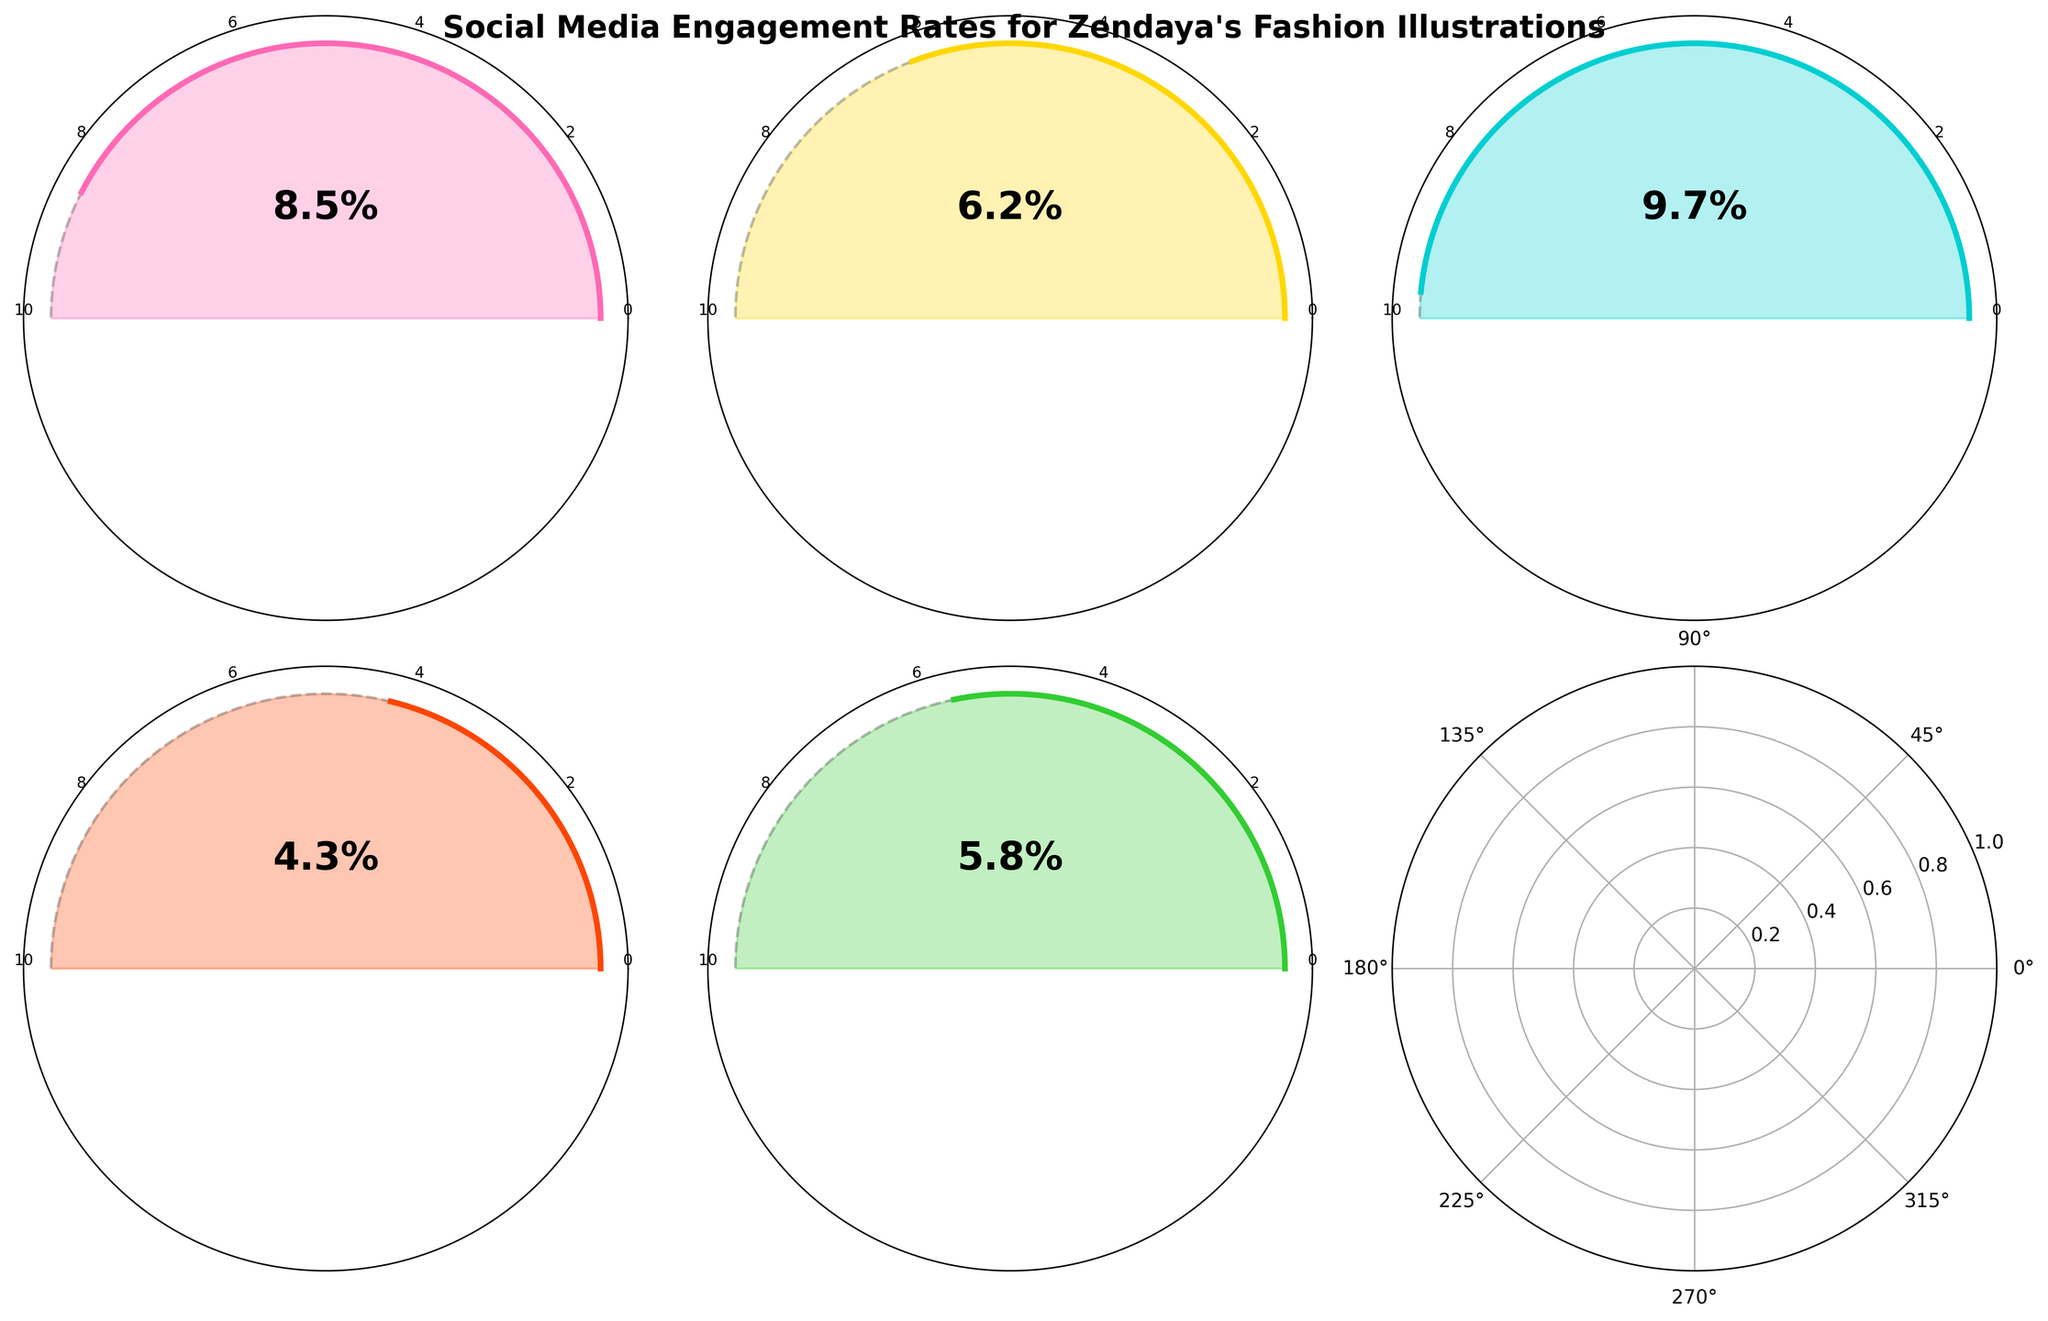Which platform has the highest engagement rate? To determine the highest engagement rate, look at the rates listed for each platform and identify the maximum value. TikTok has an engagement rate of 9.7%, which is higher than the others.
Answer: TikTok Which platform has the lowest engagement rate? Find the lowest value among the engagement rates. Twitter has the lowest engagement rate with 4.3%.
Answer: Twitter What's the average engagement rate across all platforms? Sum all the engagement rates and divide by the number of platforms: (8.5 + 6.2 + 9.7 + 4.3 + 5.8) / 5 = 34.5 / 5 = 6.9%.
Answer: 6.9% How much higher is TikTok’s engagement rate compared to Facebook’s? Subtract Facebook's engagement rate from TikTok's engagement rate: 9.7% - 5.8% = 3.9%.
Answer: 3.9% What's the total sum of engagement rates for Instagram and Pinterest? Add the engagement rates for Instagram and Pinterest: 8.5% + 6.2% = 14.7%.
Answer: 14.7% How does Facebook’s engagement rate compare to Twitter’s? Compare the engagement rates of Facebook and Twitter: 5.8% is greater than 4.3%.
Answer: Higher Rank the platforms in descending order of their engagement rates. Order the engagement rates from highest to lowest: TikTok (9.7%), Instagram (8.5%), Pinterest (6.2%), Facebook (5.8%), Twitter (4.3%).
Answer: TikTok, Instagram, Pinterest, Facebook, Twitter How many platforms have an engagement rate above the average? Count the number of platforms with an engagement rate higher than 6.9%. TikTok (9.7%) and Instagram (8.5%) are above the average.
Answer: 2 